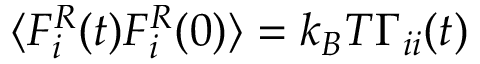Convert formula to latex. <formula><loc_0><loc_0><loc_500><loc_500>\langle F _ { i } ^ { R } ( t ) F _ { i } ^ { R } ( 0 ) \rangle = k _ { B } T \Gamma _ { i i } ( t )</formula> 